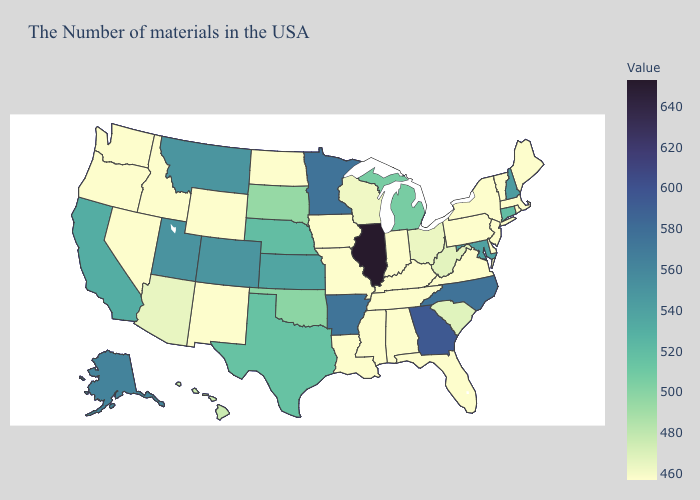Among the states that border Michigan , does Ohio have the lowest value?
Be succinct. No. Among the states that border Tennessee , which have the lowest value?
Keep it brief. Virginia, Kentucky, Alabama, Mississippi, Missouri. Which states have the lowest value in the Northeast?
Be succinct. Maine, Massachusetts, Rhode Island, Vermont, New York, New Jersey, Pennsylvania. Does Florida have the highest value in the South?
Be succinct. No. Among the states that border Texas , which have the lowest value?
Be succinct. Louisiana, New Mexico. Does the map have missing data?
Be succinct. No. Does Maryland have the lowest value in the South?
Be succinct. No. 